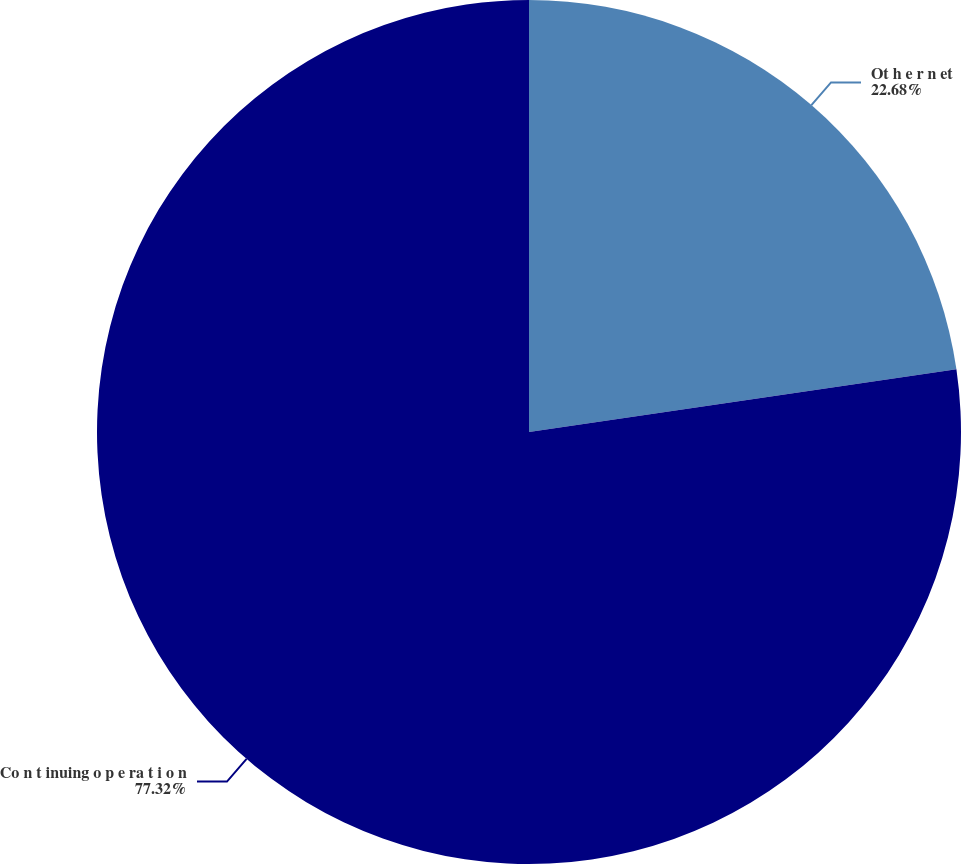Convert chart to OTSL. <chart><loc_0><loc_0><loc_500><loc_500><pie_chart><fcel>Ot h e r n et<fcel>Co n t inuing o p e ra t i o n<nl><fcel>22.68%<fcel>77.32%<nl></chart> 